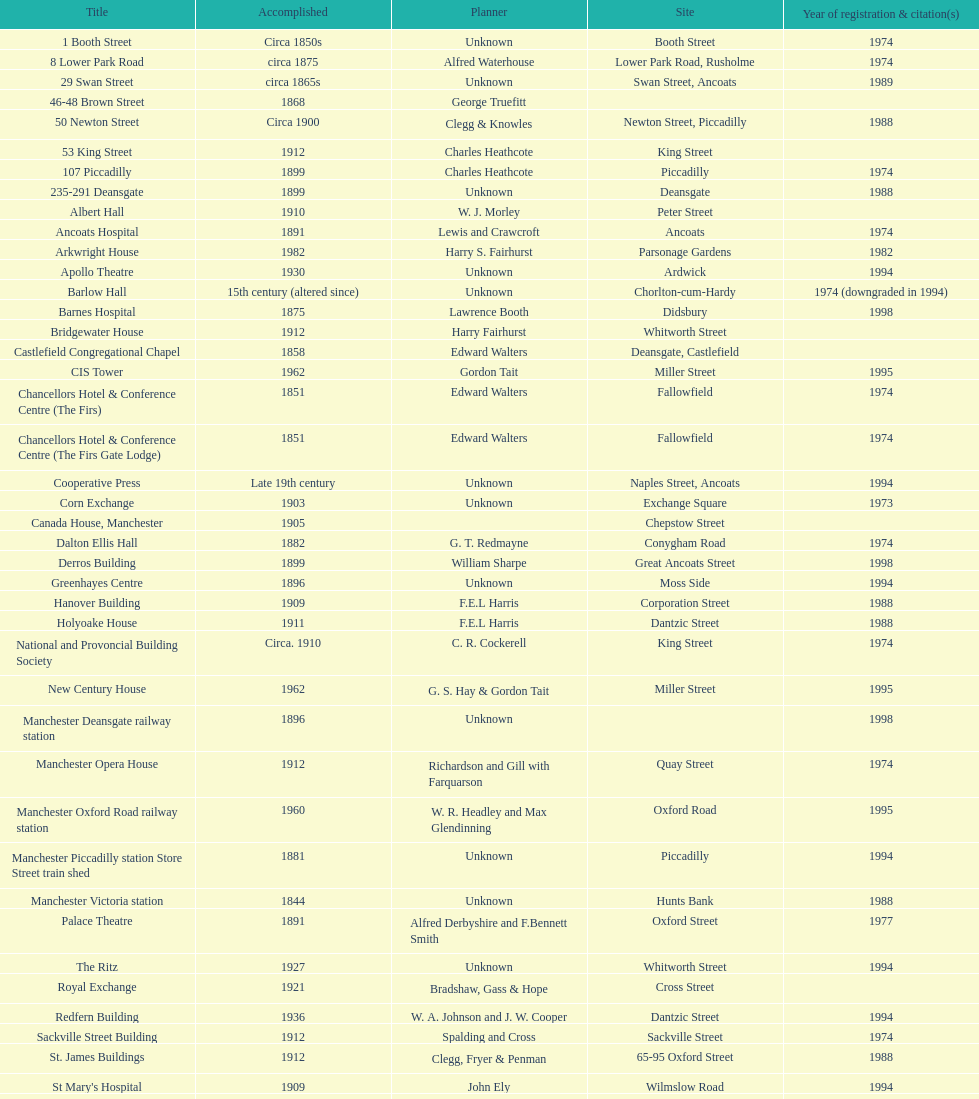What is the difference, in years, between the completion dates of 53 king street and castlefield congregational chapel? 54 years. 